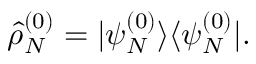Convert formula to latex. <formula><loc_0><loc_0><loc_500><loc_500>\hat { \rho } _ { N } ^ { ( 0 ) } = | \psi _ { N } ^ { ( 0 ) } \rangle \langle \psi _ { N } ^ { ( 0 ) } | .</formula> 